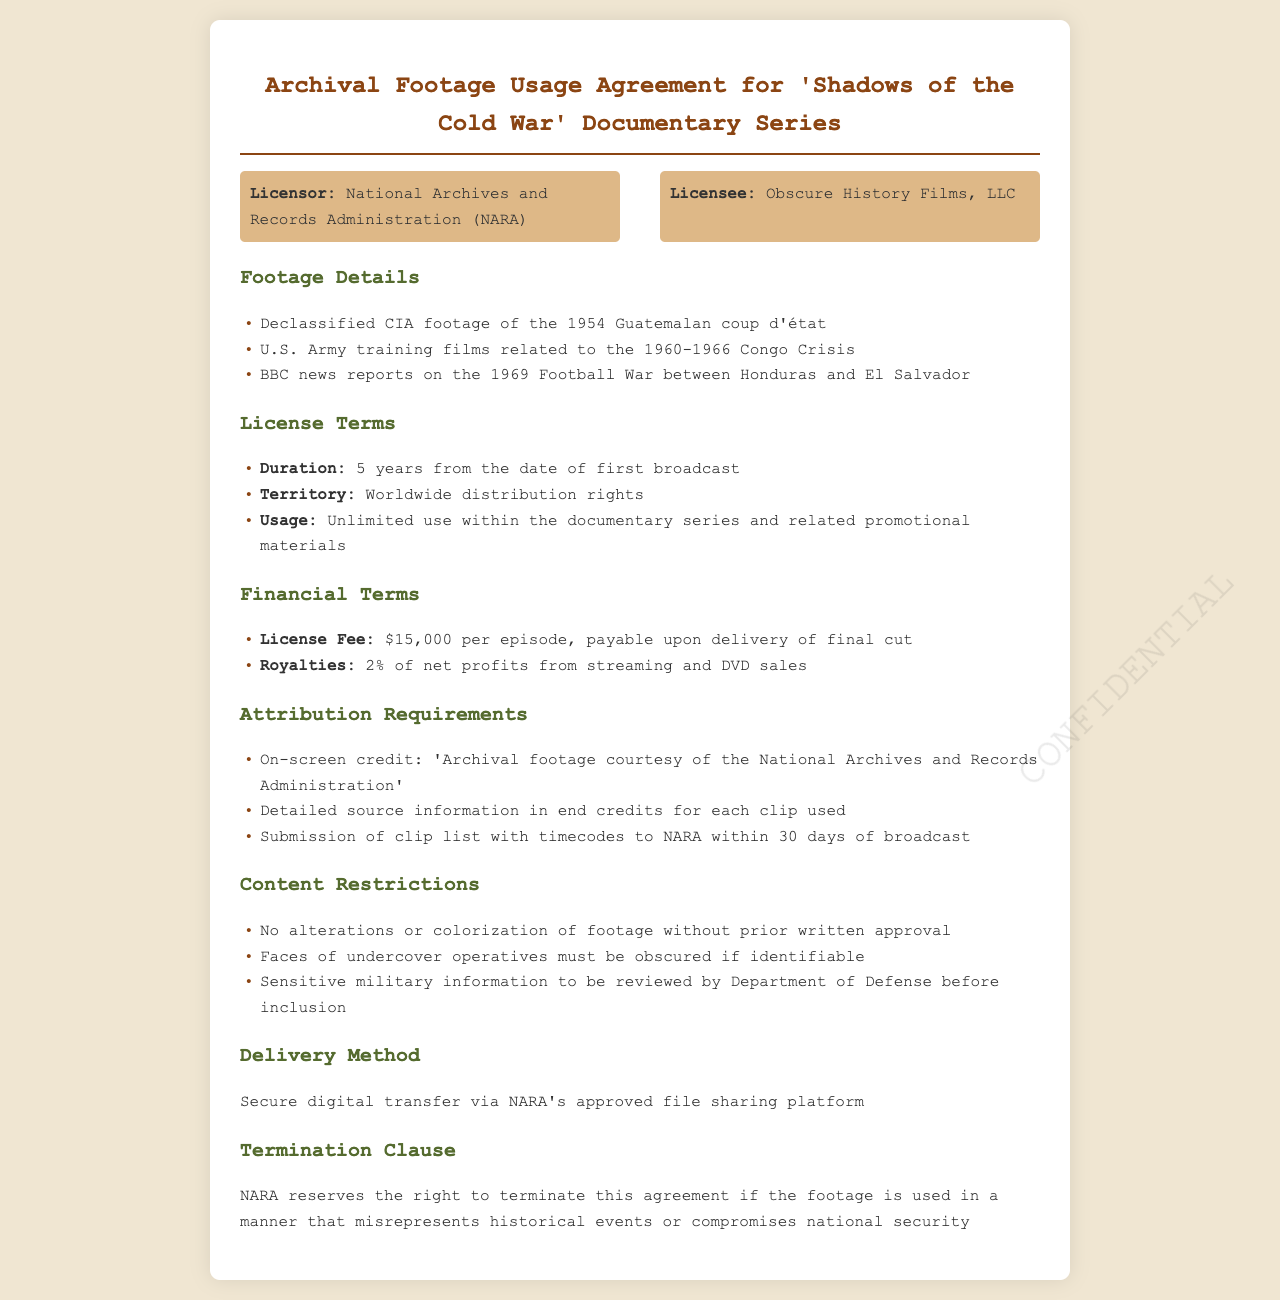What is the license fee per episode? The license fee is directly stated in the financial terms section of the document.
Answer: $15,000 Who is the licensor? The first party mentioned in the document is the licensor, which is clearly defined.
Answer: National Archives and Records Administration (NARA) What is the duration of the license? The duration is specified in the license terms section as the time frame allowed for the use of the footage.
Answer: 5 years What must be included in end credits for each clip used? The attribution requirements outline specific information that must be provided in the credits for clarity.
Answer: Detailed source information What right does NARA retain regarding the agreement? The termination clause explains the conditions under which the licensor can end the agreement.
Answer: Terminate What condition must be met for face obscuration? Content restrictions specify conditions under which certain visual information must be altered.
Answer: If identifiable What payment is due upon delivery? The financial terms indicate payment obligations at a specific time related to the final product.
Answer: Payable upon delivery of final cut What is the method of delivery specified? The document provides explicit details on how the footages are to be transferred between the parties.
Answer: Secure digital transfer In how many days must the clip list with timecodes be submitted? The requirement for submission of the clip list is clearly mentioned under attribution requirements.
Answer: 30 days 